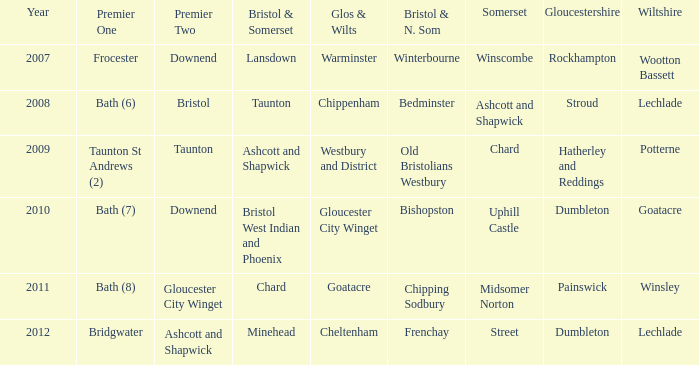Parse the table in full. {'header': ['Year', 'Premier One', 'Premier Two', 'Bristol & Somerset', 'Glos & Wilts', 'Bristol & N. Som', 'Somerset', 'Gloucestershire', 'Wiltshire'], 'rows': [['2007', 'Frocester', 'Downend', 'Lansdown', 'Warminster', 'Winterbourne', 'Winscombe', 'Rockhampton', 'Wootton Bassett'], ['2008', 'Bath (6)', 'Bristol', 'Taunton', 'Chippenham', 'Bedminster', 'Ashcott and Shapwick', 'Stroud', 'Lechlade'], ['2009', 'Taunton St Andrews (2)', 'Taunton', 'Ashcott and Shapwick', 'Westbury and District', 'Old Bristolians Westbury', 'Chard', 'Hatherley and Reddings', 'Potterne'], ['2010', 'Bath (7)', 'Downend', 'Bristol West Indian and Phoenix', 'Gloucester City Winget', 'Bishopston', 'Uphill Castle', 'Dumbleton', 'Goatacre'], ['2011', 'Bath (8)', 'Gloucester City Winget', 'Chard', 'Goatacre', 'Chipping Sodbury', 'Midsomer Norton', 'Painswick', 'Winsley'], ['2012', 'Bridgwater', 'Ashcott and Shapwick', 'Minehead', 'Cheltenham', 'Frenchay', 'Street', 'Dumbleton', 'Lechlade']]} What is the latest year where glos & wilts is warminster? 2007.0. 